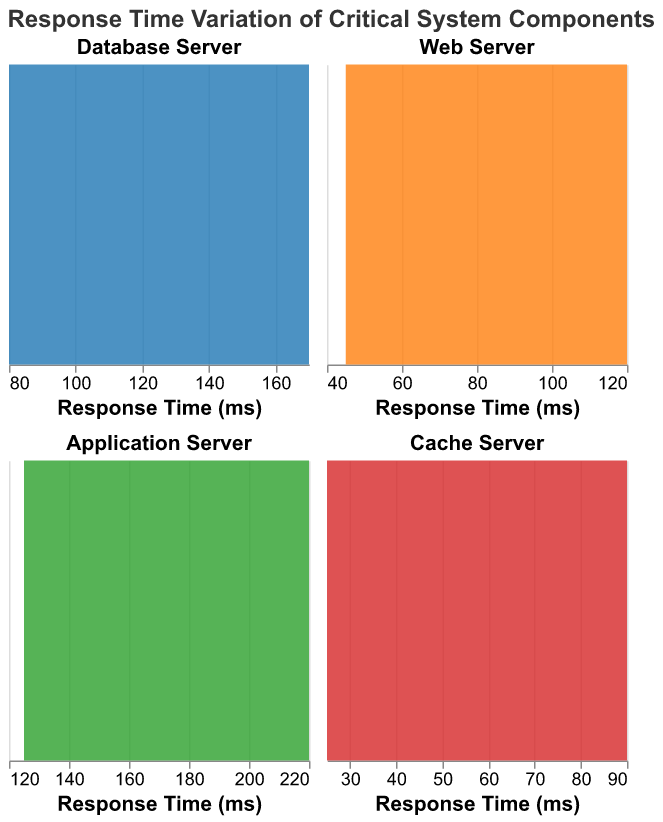What is the title of the figure? The title can be found at the top of the figure in large text. It is placed there to provide context about what the plot represents.
Answer: Response Time Variation of Critical System Components Which component has the highest peak response time during peak hours? Look at the individual density plots and identify the one with the density peak at the highest response time on the x-axis.
Answer: Application Server What color represents the Database Server in the plots? The color of the areas in each subplot can be directly seen, and the Database Server's area is colored in a specific shade.
Answer: Blue During off-peak hours, which component has the lowest peak response time? Compare the density peaks of all components during off-peak hours and find the one that has the peak at the lowest response time on the x-axis.
Answer: Cache Server Which component shows the greatest variation in response time during peak hours? Check the width of the density plot along the response time axis for each component during peak hours. The wider the plot, the greater the variation.
Answer: Application Server What is the highest response time recorded for the Web Server during peak hours? Look at the farthest point to the right within the area of the Web Server density plot which represents peak hours.
Answer: 120 ms How does the response time of the Database Server compare between peak and off-peak hours? Compare the density plots of the Database Server during peak and off-peak hours, looking at the central tendency and spread of the response times.
Answer: Peak hours have higher response times than off-peak hours Which components show a noticeable drop in response time from peak to off-peak hours? Examine the density plots for each component and identify those with a significant leftward shift in response times from peak to off-peak hours.
Answer: All components (Database Server, Web Server, Application Server, Cache Server) What is the range of response times for the Cache Server during peak hours? Identify the minimum and maximum values along the response time axis for the Cache Server density plot during peak hours.
Answer: 75 ms to 90 ms Which component has the smallest variation in response time during off-peak hours? Find the component whose density plot is most narrow during off-peak hours, indicating the least variation.
Answer: Cache Server 